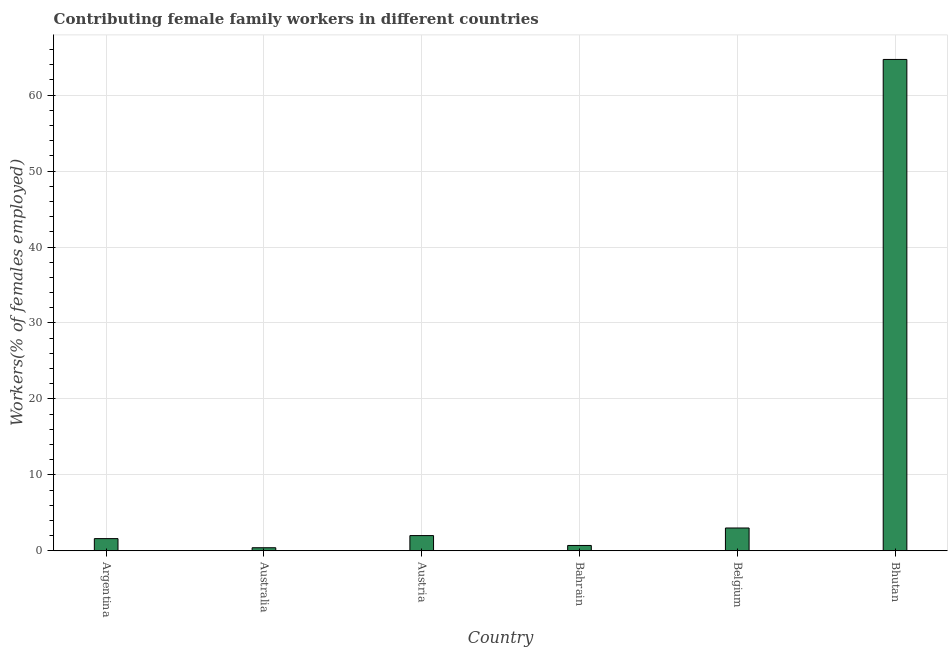Does the graph contain any zero values?
Ensure brevity in your answer.  No. Does the graph contain grids?
Provide a short and direct response. Yes. What is the title of the graph?
Ensure brevity in your answer.  Contributing female family workers in different countries. What is the label or title of the X-axis?
Your answer should be compact. Country. What is the label or title of the Y-axis?
Give a very brief answer. Workers(% of females employed). What is the contributing female family workers in Bhutan?
Make the answer very short. 64.7. Across all countries, what is the maximum contributing female family workers?
Provide a succinct answer. 64.7. Across all countries, what is the minimum contributing female family workers?
Ensure brevity in your answer.  0.4. In which country was the contributing female family workers maximum?
Your answer should be very brief. Bhutan. What is the sum of the contributing female family workers?
Offer a very short reply. 72.4. What is the difference between the contributing female family workers in Argentina and Bhutan?
Provide a short and direct response. -63.1. What is the average contributing female family workers per country?
Offer a terse response. 12.07. What is the median contributing female family workers?
Offer a terse response. 1.8. What is the ratio of the contributing female family workers in Australia to that in Bahrain?
Give a very brief answer. 0.57. Is the contributing female family workers in Austria less than that in Bahrain?
Your answer should be compact. No. Is the difference between the contributing female family workers in Austria and Bhutan greater than the difference between any two countries?
Your answer should be very brief. No. What is the difference between the highest and the second highest contributing female family workers?
Your response must be concise. 61.7. What is the difference between the highest and the lowest contributing female family workers?
Your answer should be compact. 64.3. Are all the bars in the graph horizontal?
Provide a succinct answer. No. What is the difference between two consecutive major ticks on the Y-axis?
Your answer should be very brief. 10. Are the values on the major ticks of Y-axis written in scientific E-notation?
Keep it short and to the point. No. What is the Workers(% of females employed) in Argentina?
Your response must be concise. 1.6. What is the Workers(% of females employed) in Australia?
Give a very brief answer. 0.4. What is the Workers(% of females employed) in Austria?
Ensure brevity in your answer.  2. What is the Workers(% of females employed) of Bahrain?
Keep it short and to the point. 0.7. What is the Workers(% of females employed) of Belgium?
Offer a terse response. 3. What is the Workers(% of females employed) of Bhutan?
Give a very brief answer. 64.7. What is the difference between the Workers(% of females employed) in Argentina and Austria?
Offer a terse response. -0.4. What is the difference between the Workers(% of females employed) in Argentina and Belgium?
Give a very brief answer. -1.4. What is the difference between the Workers(% of females employed) in Argentina and Bhutan?
Keep it short and to the point. -63.1. What is the difference between the Workers(% of females employed) in Australia and Austria?
Provide a short and direct response. -1.6. What is the difference between the Workers(% of females employed) in Australia and Bhutan?
Make the answer very short. -64.3. What is the difference between the Workers(% of females employed) in Austria and Bahrain?
Ensure brevity in your answer.  1.3. What is the difference between the Workers(% of females employed) in Austria and Bhutan?
Provide a succinct answer. -62.7. What is the difference between the Workers(% of females employed) in Bahrain and Belgium?
Give a very brief answer. -2.3. What is the difference between the Workers(% of females employed) in Bahrain and Bhutan?
Your answer should be compact. -64. What is the difference between the Workers(% of females employed) in Belgium and Bhutan?
Your answer should be very brief. -61.7. What is the ratio of the Workers(% of females employed) in Argentina to that in Bahrain?
Keep it short and to the point. 2.29. What is the ratio of the Workers(% of females employed) in Argentina to that in Belgium?
Offer a very short reply. 0.53. What is the ratio of the Workers(% of females employed) in Argentina to that in Bhutan?
Your response must be concise. 0.03. What is the ratio of the Workers(% of females employed) in Australia to that in Bahrain?
Offer a terse response. 0.57. What is the ratio of the Workers(% of females employed) in Australia to that in Belgium?
Your response must be concise. 0.13. What is the ratio of the Workers(% of females employed) in Australia to that in Bhutan?
Provide a succinct answer. 0.01. What is the ratio of the Workers(% of females employed) in Austria to that in Bahrain?
Provide a short and direct response. 2.86. What is the ratio of the Workers(% of females employed) in Austria to that in Belgium?
Your answer should be compact. 0.67. What is the ratio of the Workers(% of females employed) in Austria to that in Bhutan?
Offer a very short reply. 0.03. What is the ratio of the Workers(% of females employed) in Bahrain to that in Belgium?
Offer a terse response. 0.23. What is the ratio of the Workers(% of females employed) in Bahrain to that in Bhutan?
Offer a terse response. 0.01. What is the ratio of the Workers(% of females employed) in Belgium to that in Bhutan?
Give a very brief answer. 0.05. 